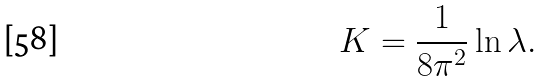Convert formula to latex. <formula><loc_0><loc_0><loc_500><loc_500>K = \frac { 1 } { 8 \pi ^ { 2 } } \ln \lambda .</formula> 